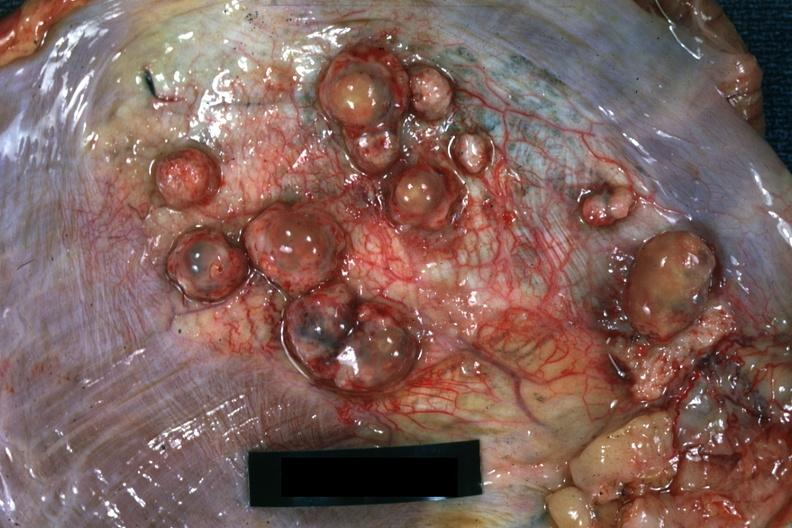does this image show close-up of tumor nodules in diaphragm?
Answer the question using a single word or phrase. Yes 